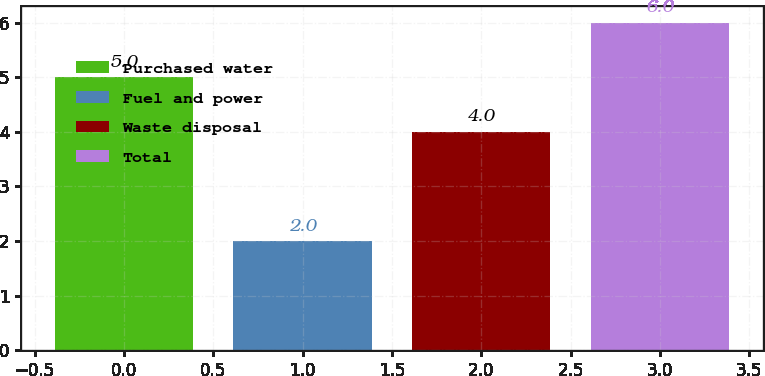Convert chart to OTSL. <chart><loc_0><loc_0><loc_500><loc_500><bar_chart><fcel>Purchased water<fcel>Fuel and power<fcel>Waste disposal<fcel>Total<nl><fcel>5<fcel>2<fcel>4<fcel>6<nl></chart> 